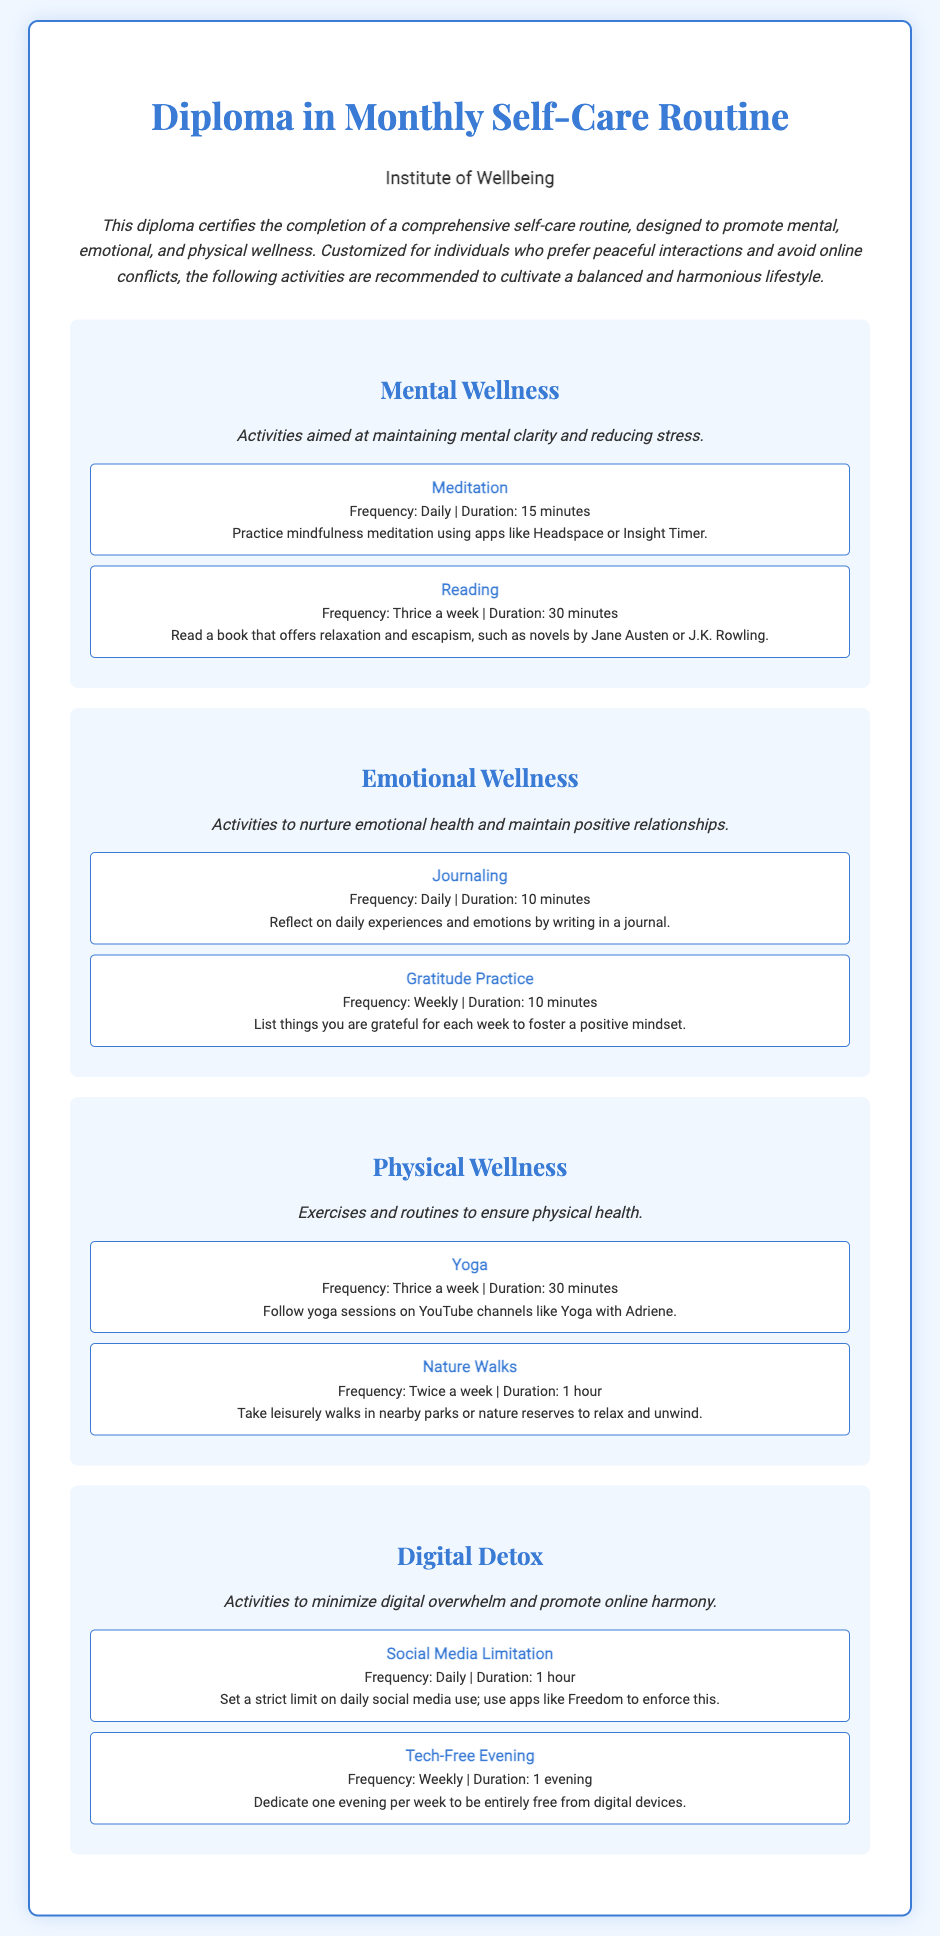What is the title of the diploma? The title of the diploma is stated at the top of the document.
Answer: Diploma in Monthly Self-Care Routine Who issued the diploma? The diploma specifies the institution that issued it, which is mentioned below the title.
Answer: Institute of Wellbeing What category includes journaling? The category that includes journaling is labeled in the document, which is one of the sections outlined.
Answer: Emotional Wellness How often should meditation be practiced? The frequency of meditation is detailed in the activities section under mental wellness.
Answer: Daily What is the duration of nature walks? The duration for nature walks is clearly mentioned in the physical wellness activities section.
Answer: 1 hour How many times a week is yoga recommended? The frequency of yoga is provided in the physical wellness activities section.
Answer: Thrice a week What is the main focus of the Digital Detox category? The main focus is summarized in the description of the category within the document.
Answer: Minimize digital overwhelm What type of activity is listed under Social Media Limitation? This refers to a specific activity described under digital detox, indicating its nature and purpose.
Answer: Activity to limit social media use What should be done during a Tech-Free Evening? The guideline for this activity specifies the intended action for that evening.
Answer: Be entirely free from digital devices 